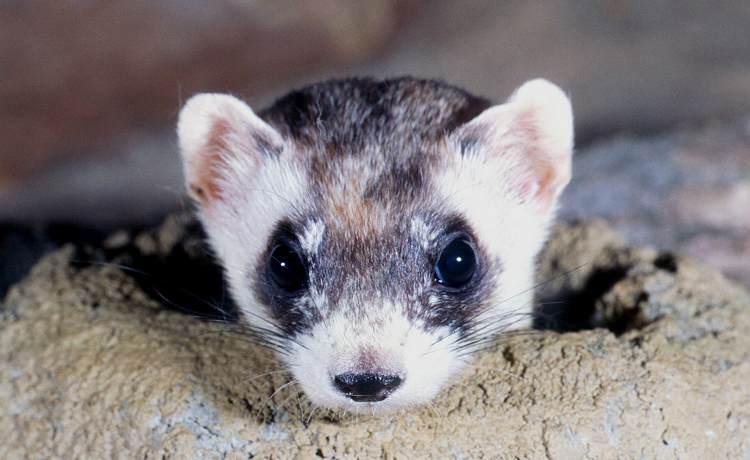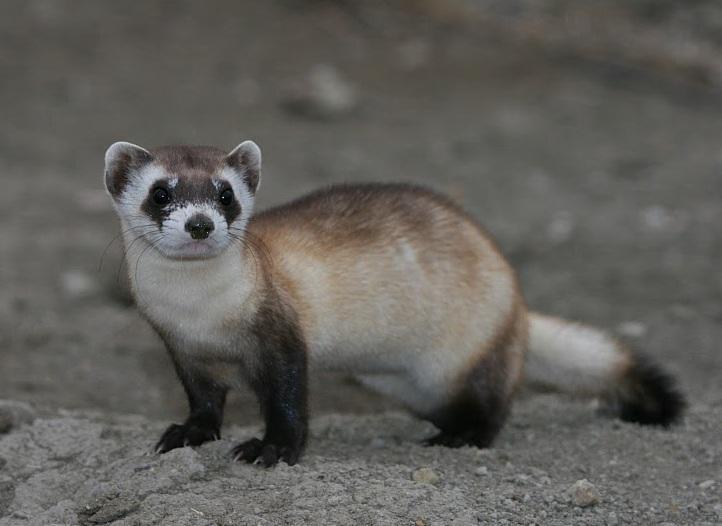The first image is the image on the left, the second image is the image on the right. Assess this claim about the two images: "The left animal is mostly underground, the right animal is entirely above ground.". Correct or not? Answer yes or no. Yes. 